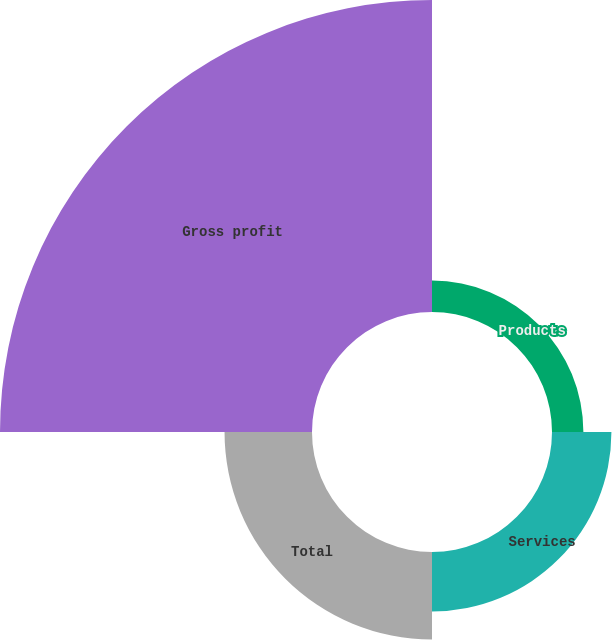<chart> <loc_0><loc_0><loc_500><loc_500><pie_chart><fcel>Products<fcel>Services<fcel>Total<fcel>Gross profit<nl><fcel>6.4%<fcel>12.12%<fcel>17.84%<fcel>63.64%<nl></chart> 